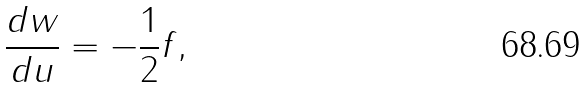<formula> <loc_0><loc_0><loc_500><loc_500>\frac { d w } { d u } = - \frac { 1 } { 2 } f ,</formula> 